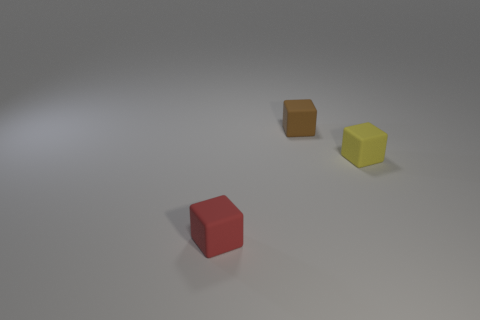What's the texture of the surface the cubes are resting on? The surface looks smooth and matte with minimal reflection, suggesting it might be some form of unpolished or satin-finished material. 